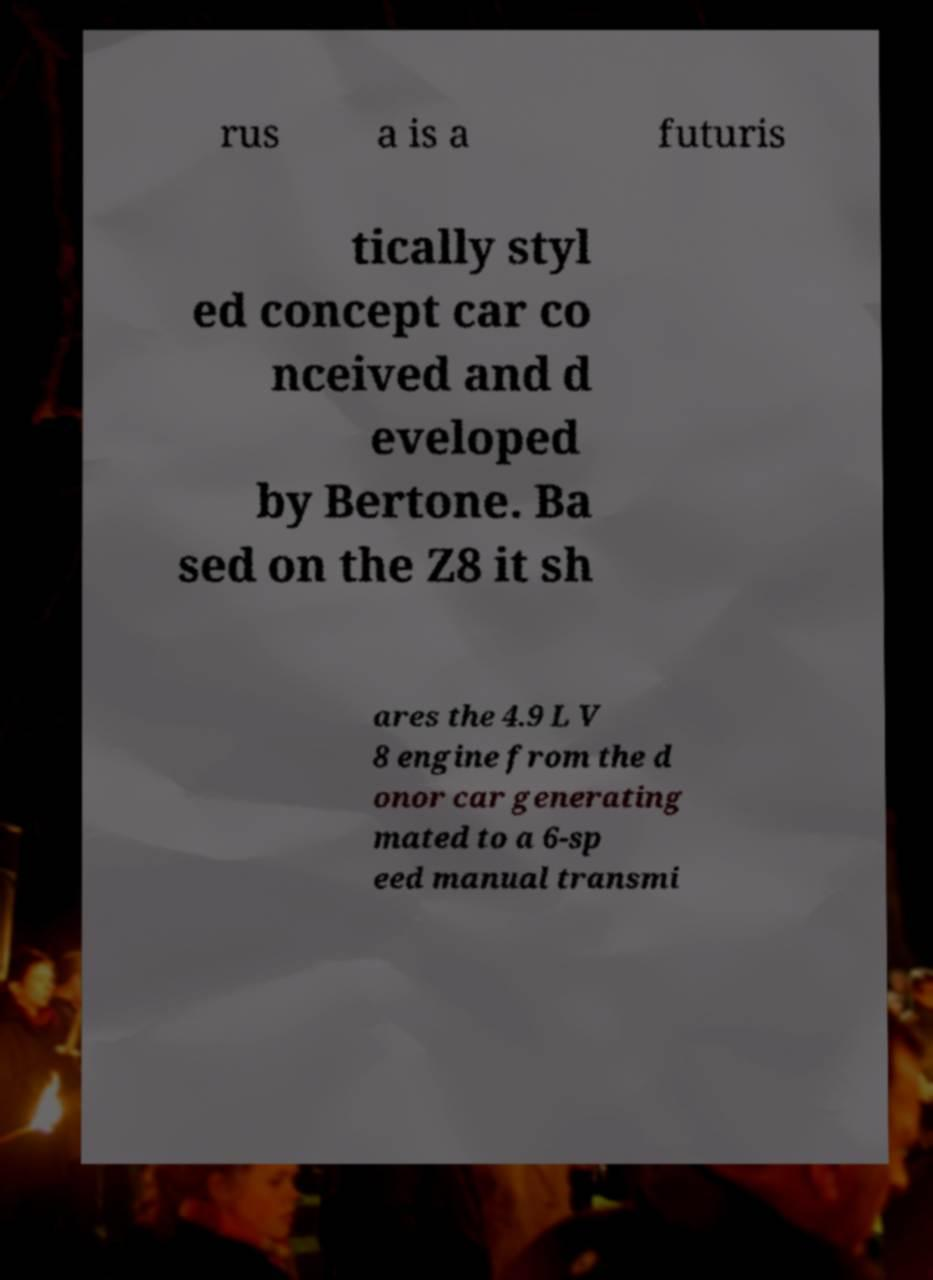I need the written content from this picture converted into text. Can you do that? rus a is a futuris tically styl ed concept car co nceived and d eveloped by Bertone. Ba sed on the Z8 it sh ares the 4.9 L V 8 engine from the d onor car generating mated to a 6-sp eed manual transmi 